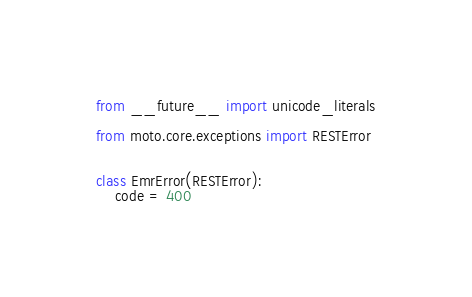Convert code to text. <code><loc_0><loc_0><loc_500><loc_500><_Python_>from __future__ import unicode_literals

from moto.core.exceptions import RESTError


class EmrError(RESTError):
    code = 400
</code> 